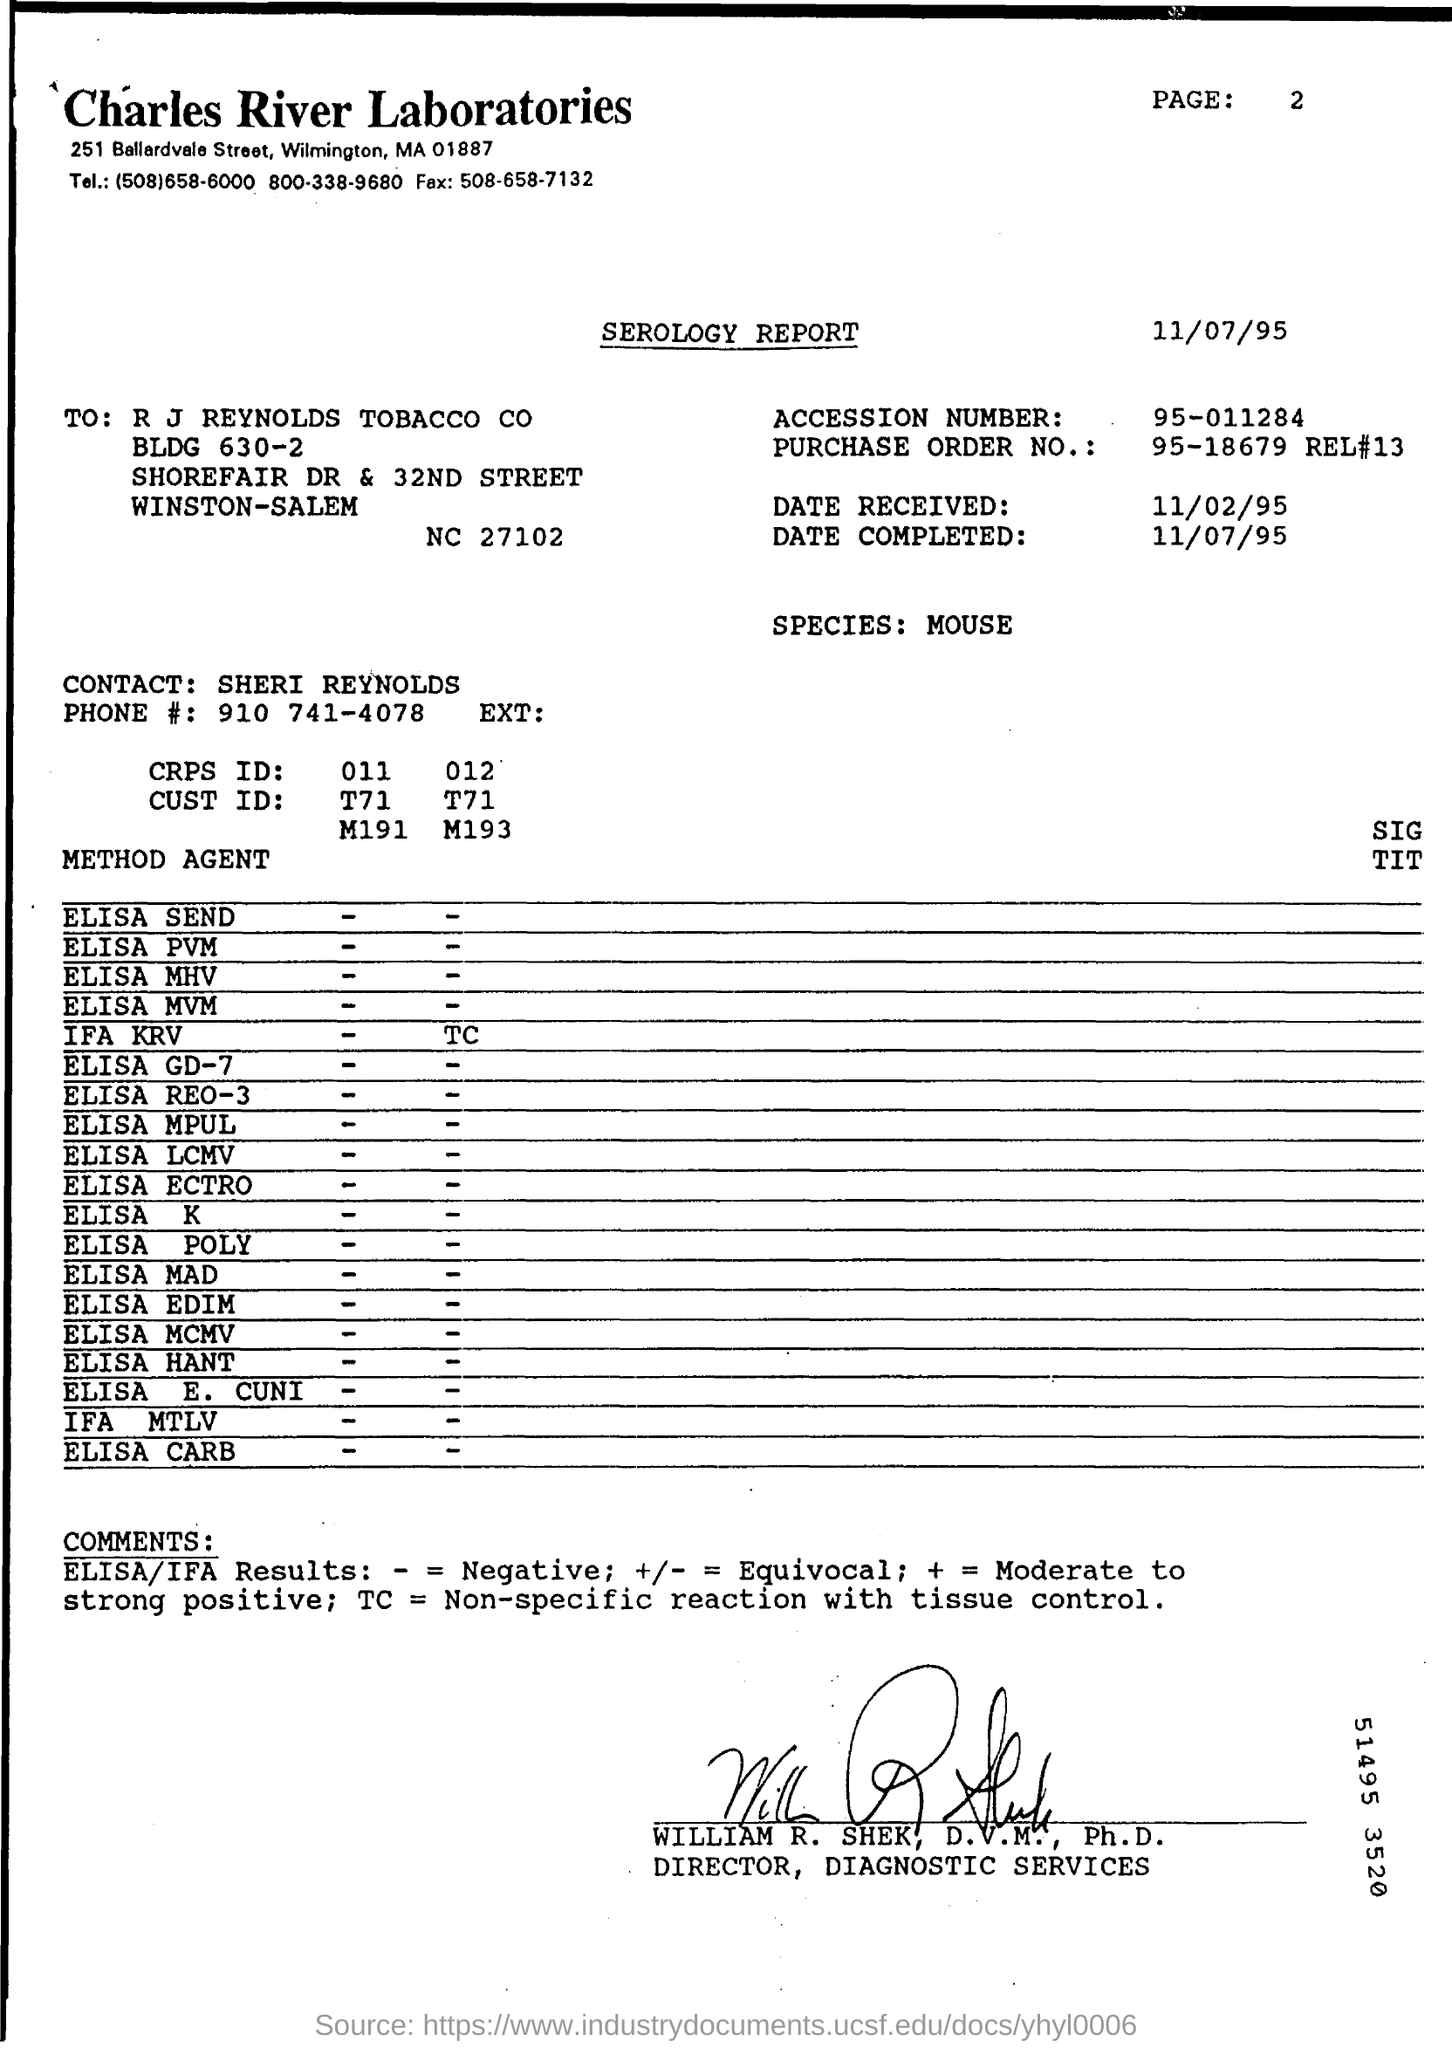What kind of report is given here?
Your response must be concise. SEROLOGY REPORT. Which Laboratory's report is this?
Your response must be concise. Charles River Laboratories. What kind of species is used for the test?
Your response must be concise. MOUSE. Who is the contact person given in the report?
Give a very brief answer. SHERI REYNOLDS. What is the Accession Number mentioned in the report?
Keep it short and to the point. 95-011284. Who has signed the report?
Your answer should be compact. WILLIAM R.  SHEK. 